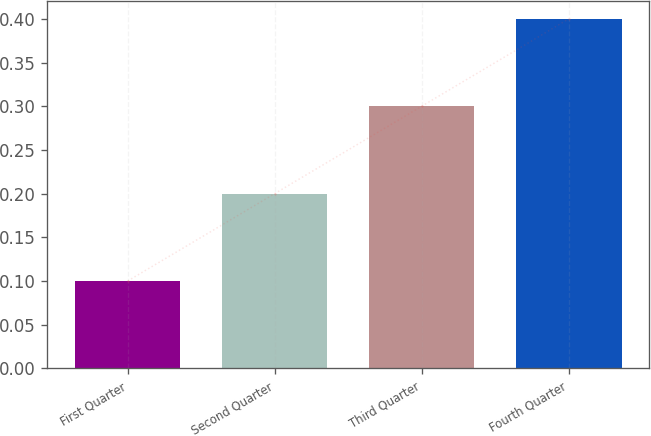Convert chart. <chart><loc_0><loc_0><loc_500><loc_500><bar_chart><fcel>First Quarter<fcel>Second Quarter<fcel>Third Quarter<fcel>Fourth Quarter<nl><fcel>0.1<fcel>0.2<fcel>0.3<fcel>0.4<nl></chart> 